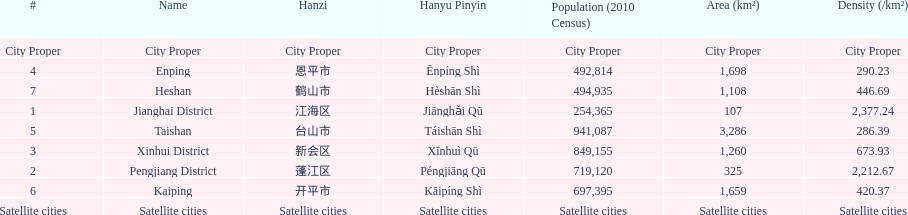What is the difference in population between enping and heshan? 2121. 